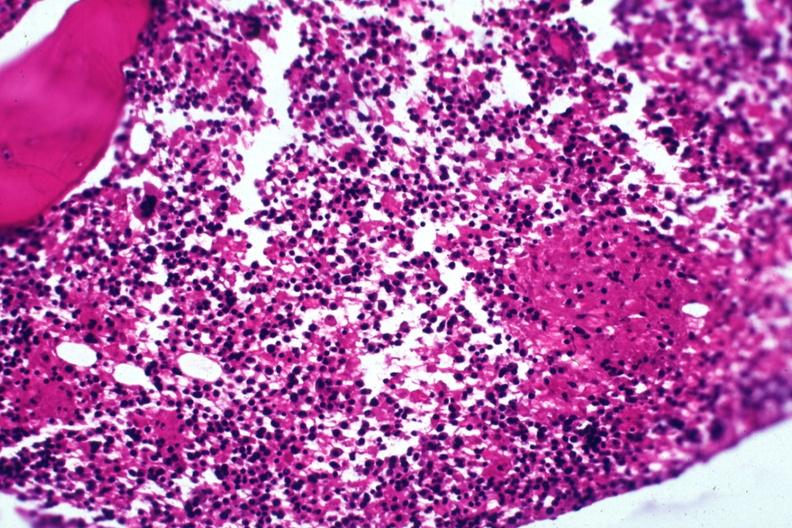s hematologic present?
Answer the question using a single word or phrase. Yes 